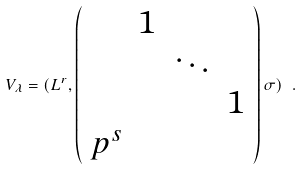Convert formula to latex. <formula><loc_0><loc_0><loc_500><loc_500>V _ { \lambda } = ( L ^ { r } , \left ( \begin{array} { c c c c } & 1 & & \\ & & \ddots & \\ & & & 1 \\ p ^ { s } & & & \end{array} \right ) \sigma ) \ .</formula> 